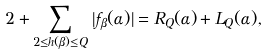<formula> <loc_0><loc_0><loc_500><loc_500>2 + \sum _ { 2 \leq h ( \beta ) \leq Q } | f _ { \beta } ( \alpha ) | = R _ { Q } ( \alpha ) + L _ { Q } ( \alpha ) ,</formula> 